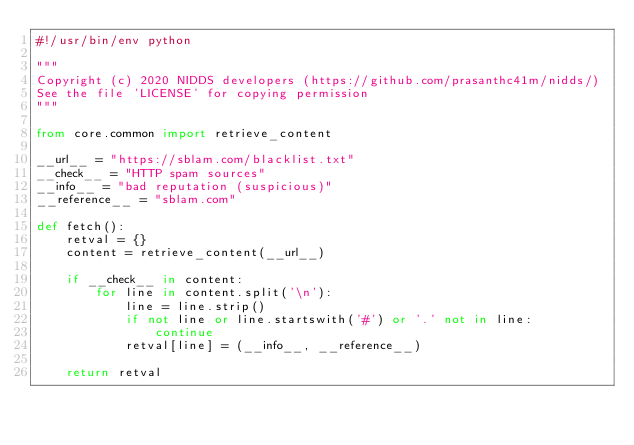Convert code to text. <code><loc_0><loc_0><loc_500><loc_500><_Python_>#!/usr/bin/env python

"""
Copyright (c) 2020 NIDDS developers (https://github.com/prasanthc41m/nidds/)
See the file 'LICENSE' for copying permission
"""

from core.common import retrieve_content

__url__ = "https://sblam.com/blacklist.txt"
__check__ = "HTTP spam sources"
__info__ = "bad reputation (suspicious)"
__reference__ = "sblam.com"

def fetch():
    retval = {}
    content = retrieve_content(__url__)

    if __check__ in content:
        for line in content.split('\n'):
            line = line.strip()
            if not line or line.startswith('#') or '.' not in line:
                continue
            retval[line] = (__info__, __reference__)

    return retval
</code> 